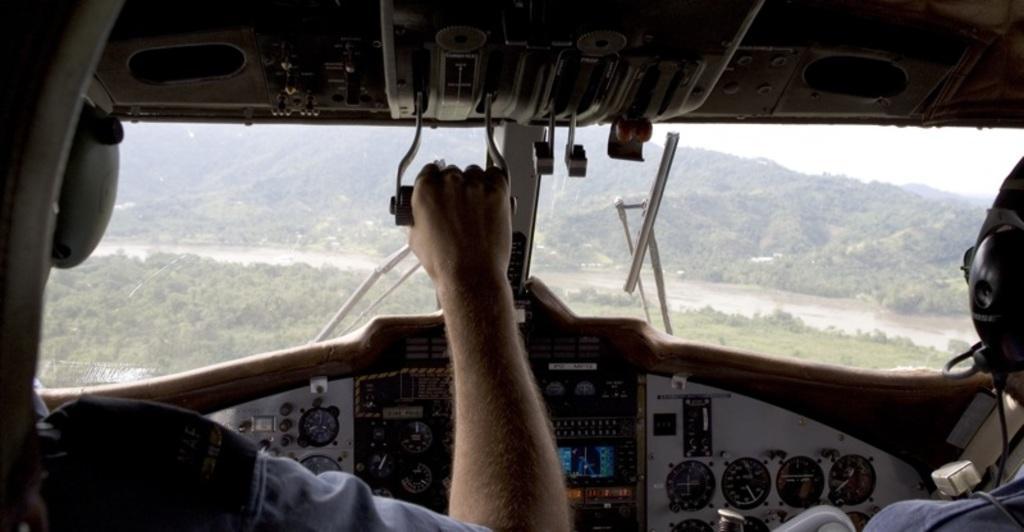Can you describe this image briefly? In this picture I can see there are two pilots and this person is holding object and in the backdrop there are some trees, mountains and the sky is clear. 